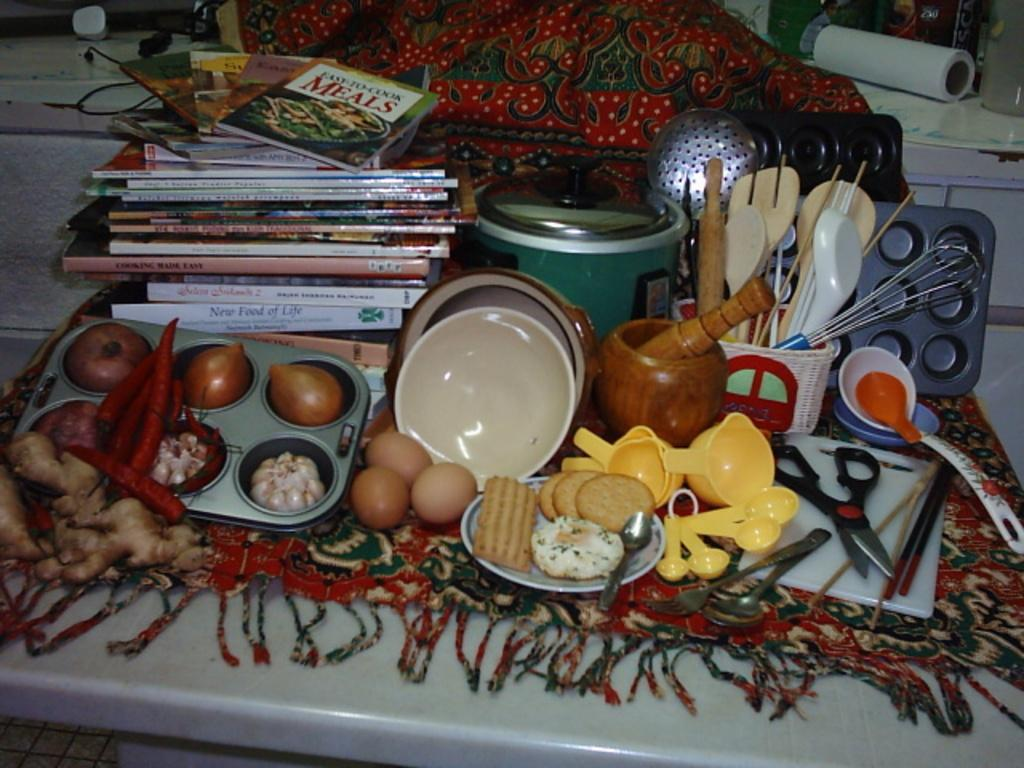What is the main object in the image? There is a cloth in the image. What is placed on the cloth? There are books and food items on the cloth. Are there any other items on the cloth besides books and food? Yes, there are other unspecified items on the cloth. How many clocks are visible on the cloth in the image? There is no mention of clocks in the image, so it cannot be determined if any are present. 